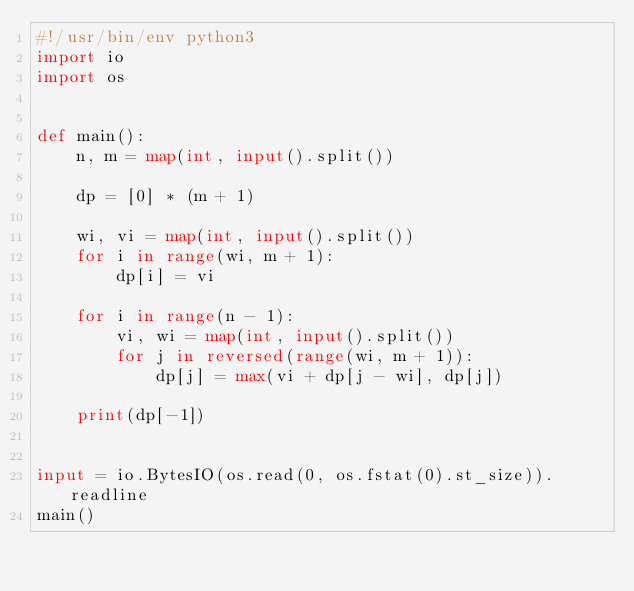Convert code to text. <code><loc_0><loc_0><loc_500><loc_500><_Python_>#!/usr/bin/env python3
import io
import os


def main():
    n, m = map(int, input().split())

    dp = [0] * (m + 1)

    wi, vi = map(int, input().split())
    for i in range(wi, m + 1):
        dp[i] = vi

    for i in range(n - 1):
        vi, wi = map(int, input().split())
        for j in reversed(range(wi, m + 1)):
            dp[j] = max(vi + dp[j - wi], dp[j])

    print(dp[-1])


input = io.BytesIO(os.read(0, os.fstat(0).st_size)).readline
main()
</code> 